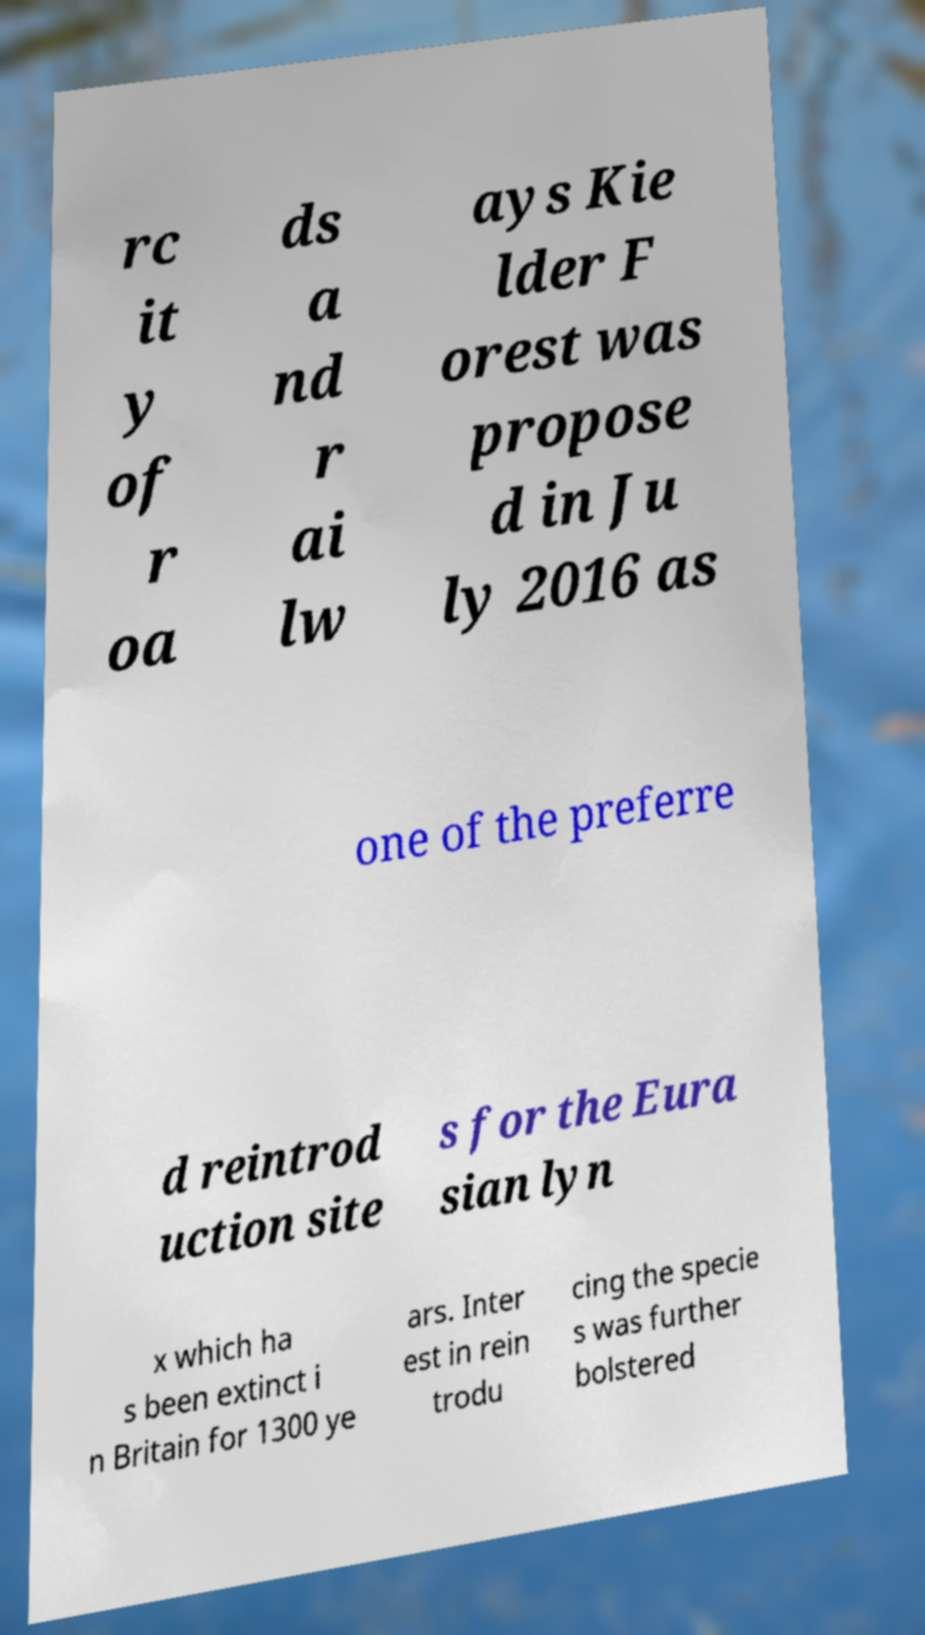Can you accurately transcribe the text from the provided image for me? rc it y of r oa ds a nd r ai lw ays Kie lder F orest was propose d in Ju ly 2016 as one of the preferre d reintrod uction site s for the Eura sian lyn x which ha s been extinct i n Britain for 1300 ye ars. Inter est in rein trodu cing the specie s was further bolstered 